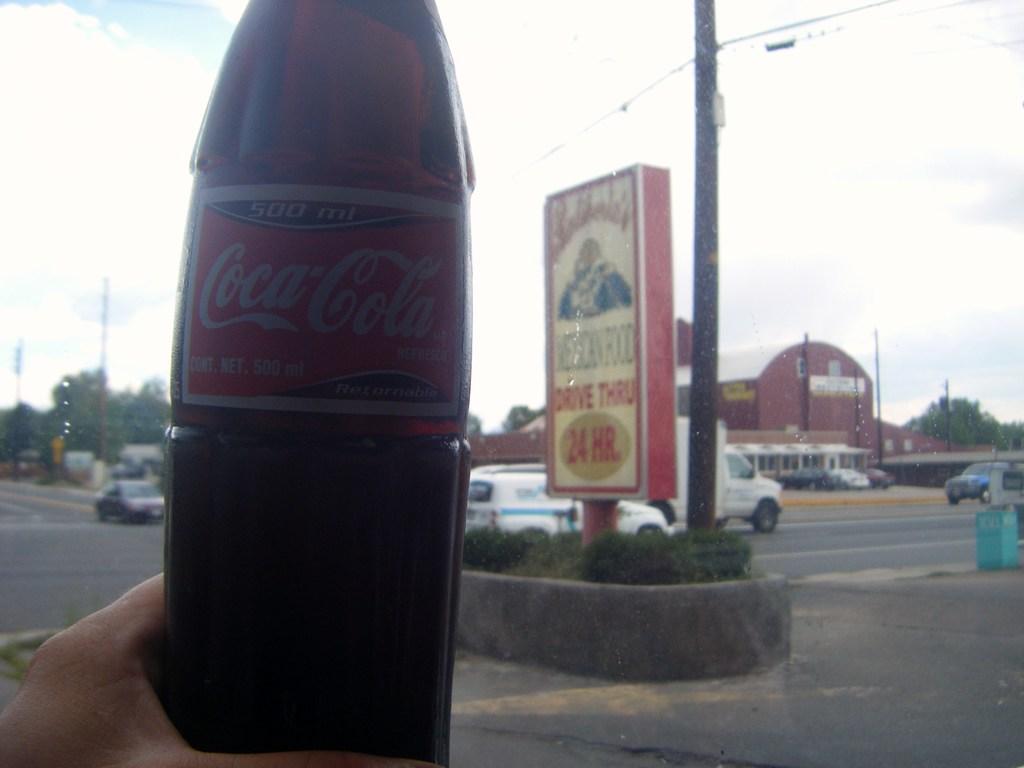What brand of soda?
Offer a terse response. Coca cola. 